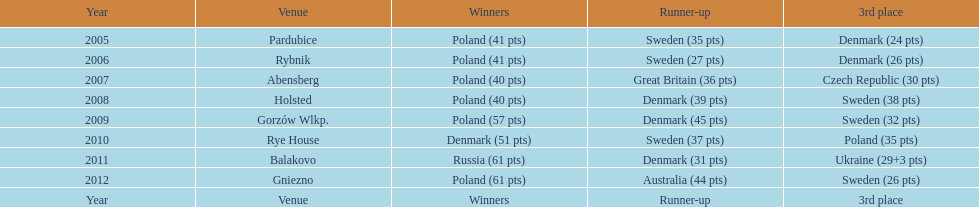From 2005-2012, in the team speedway junior world championship, how many more first place wins than all other teams put together? Poland. 